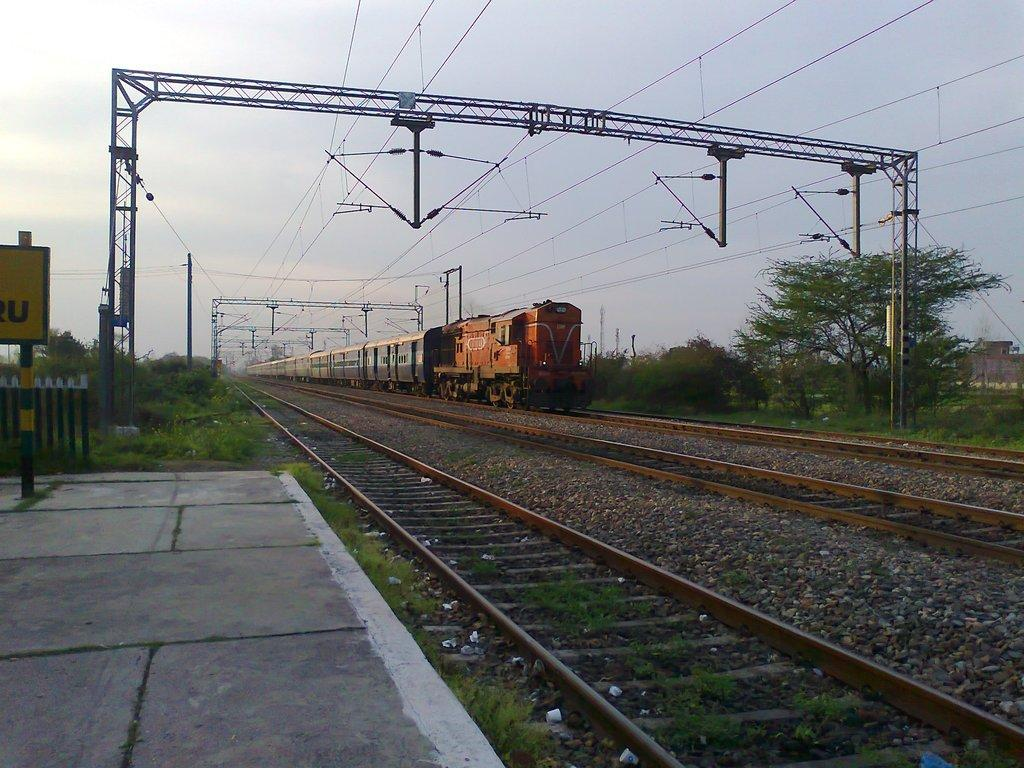What is the main subject of the image? The main subject of the image is a train on the track. What can be seen on either side of the track? There are trees and plants on either side of the track. What is present above the train? There are poles and wires above the train. What is located in the left corner of the image? There is a platform in the left corner of the image. What type of regret can be seen on the faces of the passengers in the train? There are no passengers visible in the image, and therefore no facial expressions or emotions can be observed. 